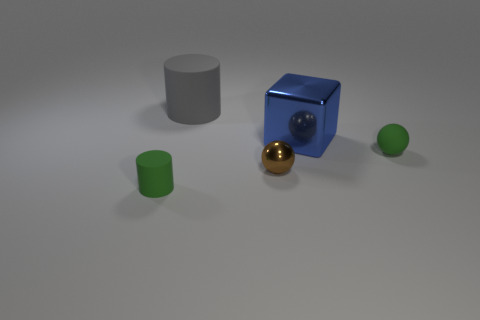There is a small thing that is on the right side of the gray matte object and on the left side of the small green rubber sphere; what shape is it?
Offer a very short reply. Sphere. How many other things are the same color as the small cylinder?
Your answer should be compact. 1. What is the shape of the gray rubber thing?
Your response must be concise. Cylinder. What is the color of the cylinder that is behind the metal thing in front of the green rubber sphere?
Make the answer very short. Gray. Does the tiny matte ball have the same color as the metal thing behind the tiny brown object?
Offer a terse response. No. There is a object that is both in front of the large blue metal object and right of the brown metallic sphere; what is it made of?
Ensure brevity in your answer.  Rubber. Is there a green matte thing of the same size as the gray matte object?
Your response must be concise. No. There is a green cylinder that is the same size as the metal sphere; what is its material?
Keep it short and to the point. Rubber. There is a blue metal object; how many green objects are on the right side of it?
Your answer should be compact. 1. There is a small green object that is on the left side of the tiny green rubber sphere; is its shape the same as the big gray thing?
Provide a succinct answer. Yes. 